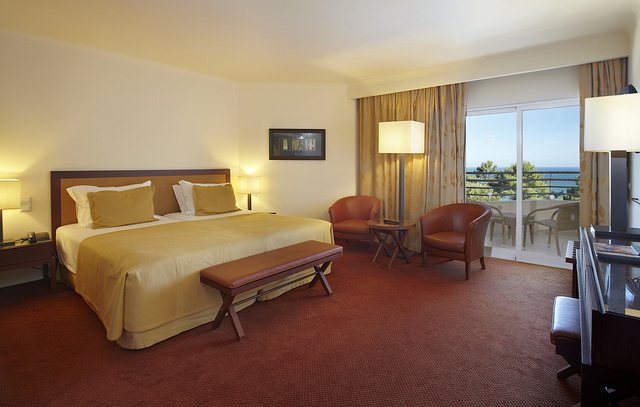Describe the view from the balcony. The balcony provides a view of a calm and serene exterior, possibly overlooking a garden or a green area with trees, under a clear or slightly cloudy sky. It appears to be a relaxing spot to enjoy the outside atmosphere. 